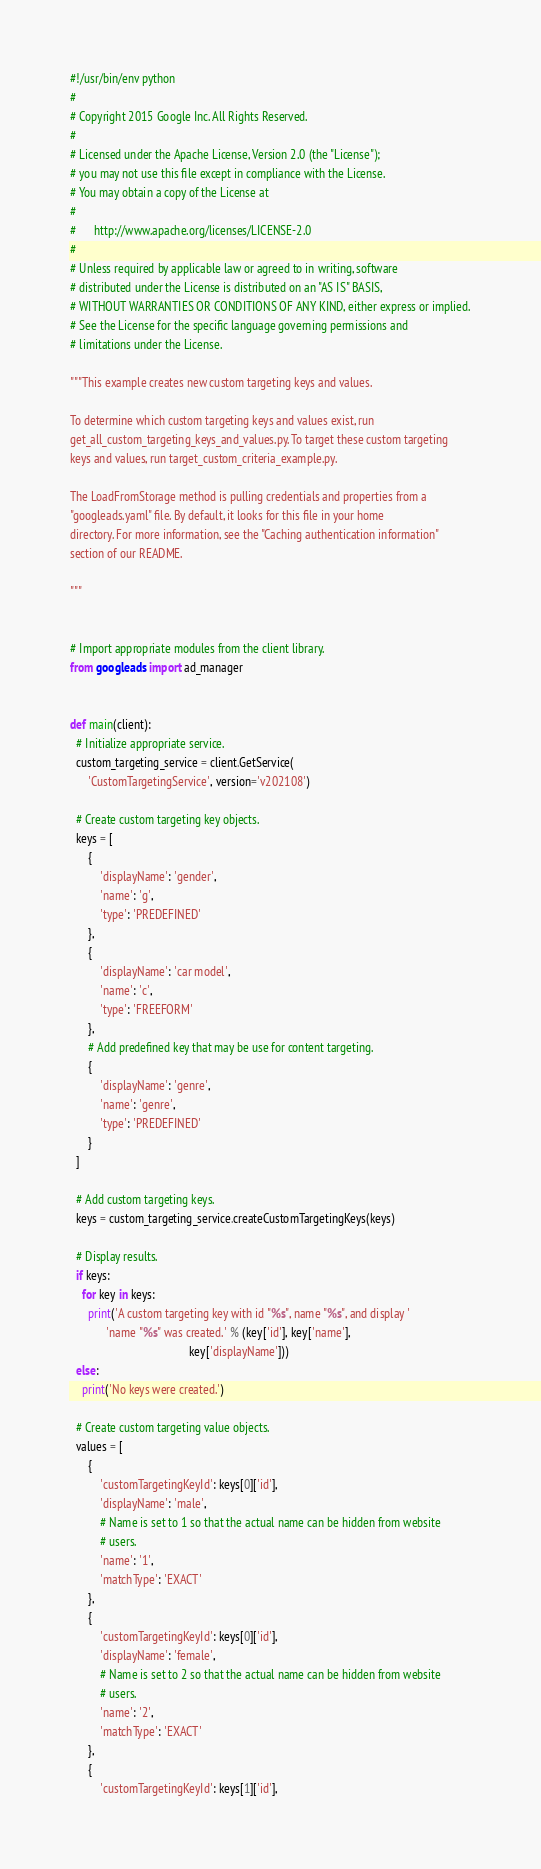<code> <loc_0><loc_0><loc_500><loc_500><_Python_>#!/usr/bin/env python
#
# Copyright 2015 Google Inc. All Rights Reserved.
#
# Licensed under the Apache License, Version 2.0 (the "License");
# you may not use this file except in compliance with the License.
# You may obtain a copy of the License at
#
#      http://www.apache.org/licenses/LICENSE-2.0
#
# Unless required by applicable law or agreed to in writing, software
# distributed under the License is distributed on an "AS IS" BASIS,
# WITHOUT WARRANTIES OR CONDITIONS OF ANY KIND, either express or implied.
# See the License for the specific language governing permissions and
# limitations under the License.

"""This example creates new custom targeting keys and values.

To determine which custom targeting keys and values exist, run
get_all_custom_targeting_keys_and_values.py. To target these custom targeting
keys and values, run target_custom_criteria_example.py.

The LoadFromStorage method is pulling credentials and properties from a
"googleads.yaml" file. By default, it looks for this file in your home
directory. For more information, see the "Caching authentication information"
section of our README.

"""


# Import appropriate modules from the client library.
from googleads import ad_manager


def main(client):
  # Initialize appropriate service.
  custom_targeting_service = client.GetService(
      'CustomTargetingService', version='v202108')

  # Create custom targeting key objects.
  keys = [
      {
          'displayName': 'gender',
          'name': 'g',
          'type': 'PREDEFINED'
      },
      {
          'displayName': 'car model',
          'name': 'c',
          'type': 'FREEFORM'
      },
      # Add predefined key that may be use for content targeting.
      {
          'displayName': 'genre',
          'name': 'genre',
          'type': 'PREDEFINED'
      }
  ]

  # Add custom targeting keys.
  keys = custom_targeting_service.createCustomTargetingKeys(keys)

  # Display results.
  if keys:
    for key in keys:
      print('A custom targeting key with id "%s", name "%s", and display '
            'name "%s" was created.' % (key['id'], key['name'],
                                        key['displayName']))
  else:
    print('No keys were created.')

  # Create custom targeting value objects.
  values = [
      {
          'customTargetingKeyId': keys[0]['id'],
          'displayName': 'male',
          # Name is set to 1 so that the actual name can be hidden from website
          # users.
          'name': '1',
          'matchType': 'EXACT'
      },
      {
          'customTargetingKeyId': keys[0]['id'],
          'displayName': 'female',
          # Name is set to 2 so that the actual name can be hidden from website
          # users.
          'name': '2',
          'matchType': 'EXACT'
      },
      {
          'customTargetingKeyId': keys[1]['id'],</code> 